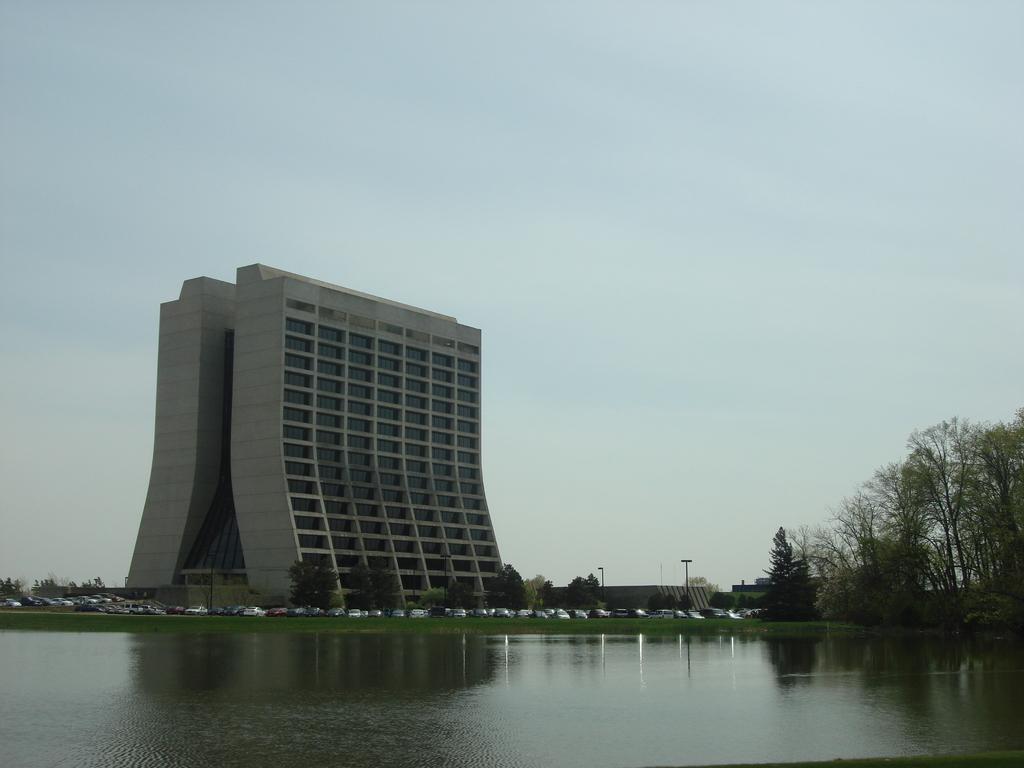Please provide a concise description of this image. In this picture we can see water, trees and few vehicles, in the background we can find few poles and buildings. 